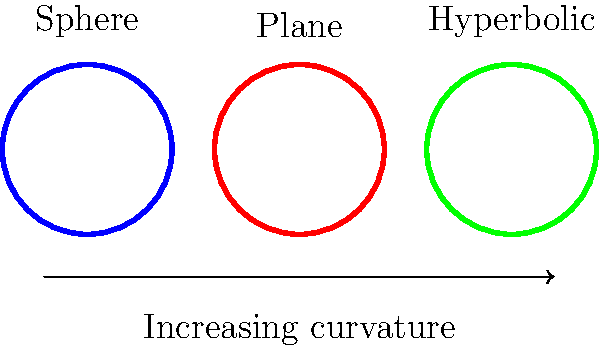As an interdisciplinary research grant overseer, you encounter a project combining geometry and biology. The researchers are studying how surface curvature affects cellular growth patterns. They model cells as circles with a fixed radius on different surfaces. Compare the areas of circles with the same radius on a sphere, a plane, and a hyperbolic surface. How does the area change as the surface curvature increases from positive (sphere) to zero (plane) to negative (hyperbolic)? To understand how the area of circles changes on different surfaces, let's analyze each case:

1. Sphere (positive curvature):
   - On a sphere, the area of a circle is given by $A_s = 4\pi R^2 \sin^2(\frac{r}{2R})$
   - Where $R$ is the radius of the sphere and $r$ is the radius of the circle
   - This area is always smaller than the area of a circle with the same radius on a plane

2. Plane (zero curvature):
   - On a plane, the area of a circle is given by the familiar formula $A_p = \pi r^2$
   - This serves as our reference point

3. Hyperbolic surface (negative curvature):
   - On a hyperbolic surface, the area of a circle is given by $A_h = 4\pi K^{-1} \sinh^2(\frac{r\sqrt{|K|}}{2})$
   - Where $K$ is the Gaussian curvature (negative) and $r$ is the radius of the circle
   - This area is always larger than the area of a circle with the same radius on a plane

As we move from positive curvature (sphere) to zero curvature (plane) to negative curvature (hyperbolic):

$A_s < A_p < A_h$

The area of the circle increases as the curvature decreases (becomes more negative). This relationship holds for circles of any fixed radius.

This geometric property has implications for cellular growth patterns, as cells on different curved surfaces would have different amounts of area available for growth and interaction, potentially affecting their behavior and organization.
Answer: The area increases as curvature decreases from positive to negative. 